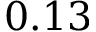Convert formula to latex. <formula><loc_0><loc_0><loc_500><loc_500>0 . 1 3</formula> 